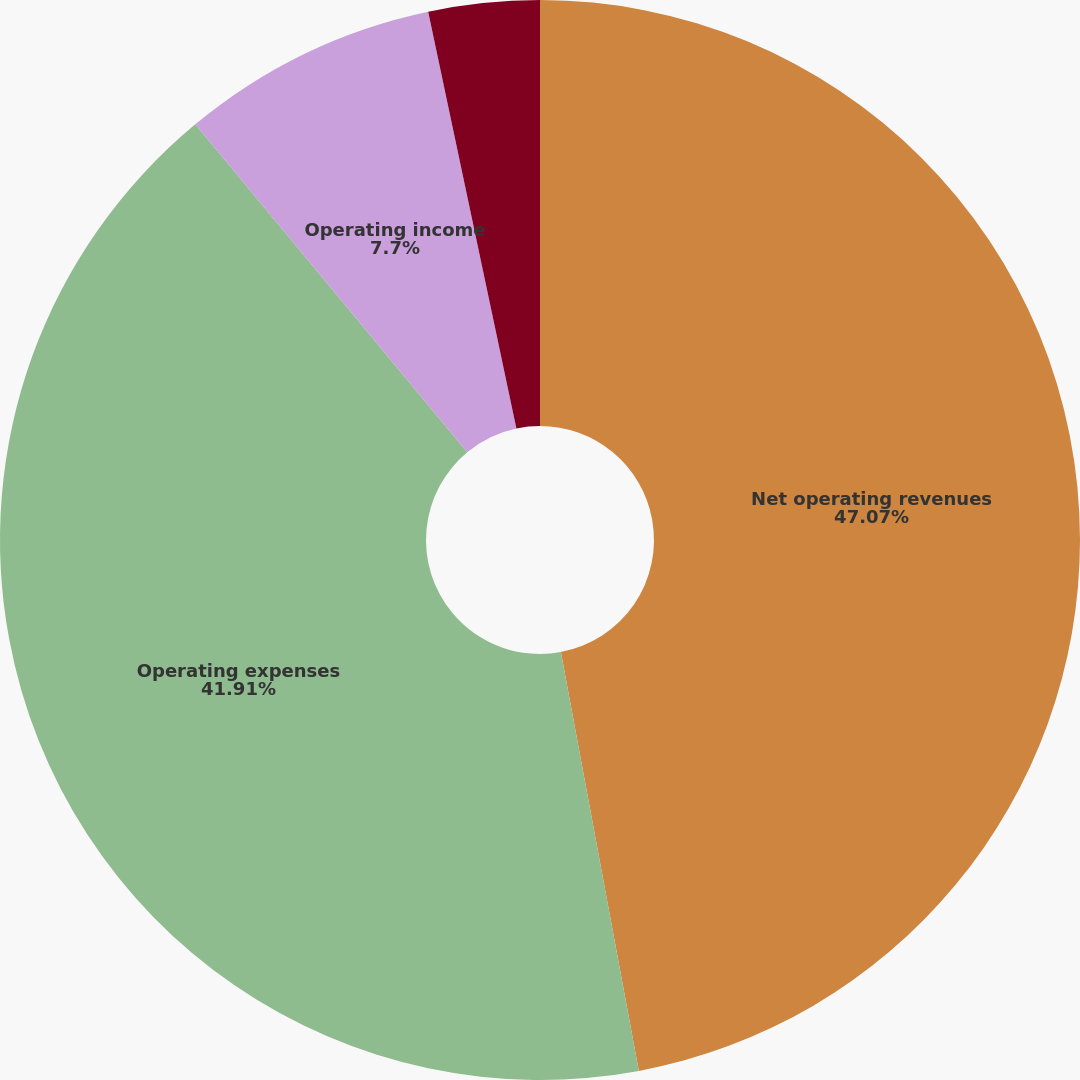Convert chart to OTSL. <chart><loc_0><loc_0><loc_500><loc_500><pie_chart><fcel>Net operating revenues<fcel>Operating expenses<fcel>Operating income<fcel>Net income<nl><fcel>47.07%<fcel>41.91%<fcel>7.7%<fcel>3.32%<nl></chart> 